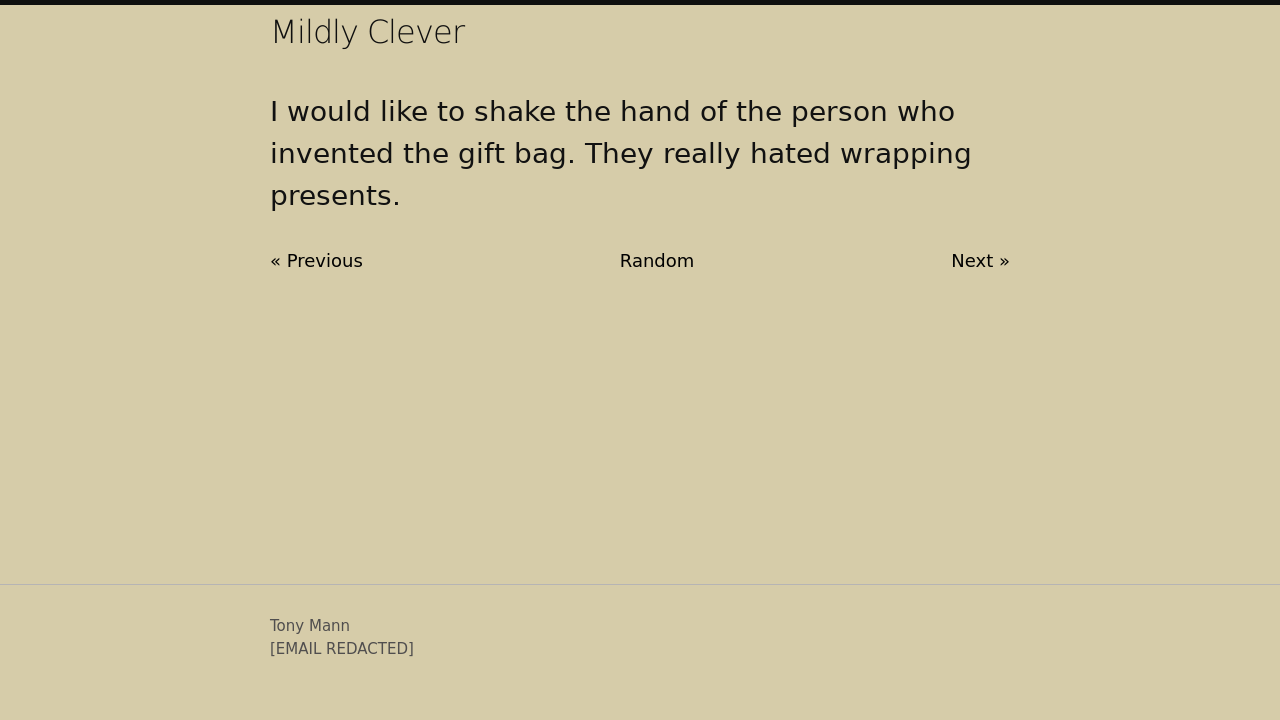Can you describe the context in which gift bags started to replace traditional gift wrapping? Gift bags became popular as a convenient alternative to traditional gift wrapping due to their ease of use. Originating in the early 20th century, they gained popularity in the 1980s when shops started offering sturdier and more decorative options. They appealed to those who found wrapping gifts time-consuming or overly complicated, simplifying the process of gift-giving.  Could the gift bag be considered eco-friendlier than traditional wrapping paper? In some aspects, yes, gift bags can be considered more eco-friendly than traditional wrapping paper. They are often reused multiple times, reducing waste. However, it depends on the material of the bag. Bags made from recycled or sustainable materials offer the most environmentally friendly option, contrasting with those crafted from plastics or non-recyclable materials. 